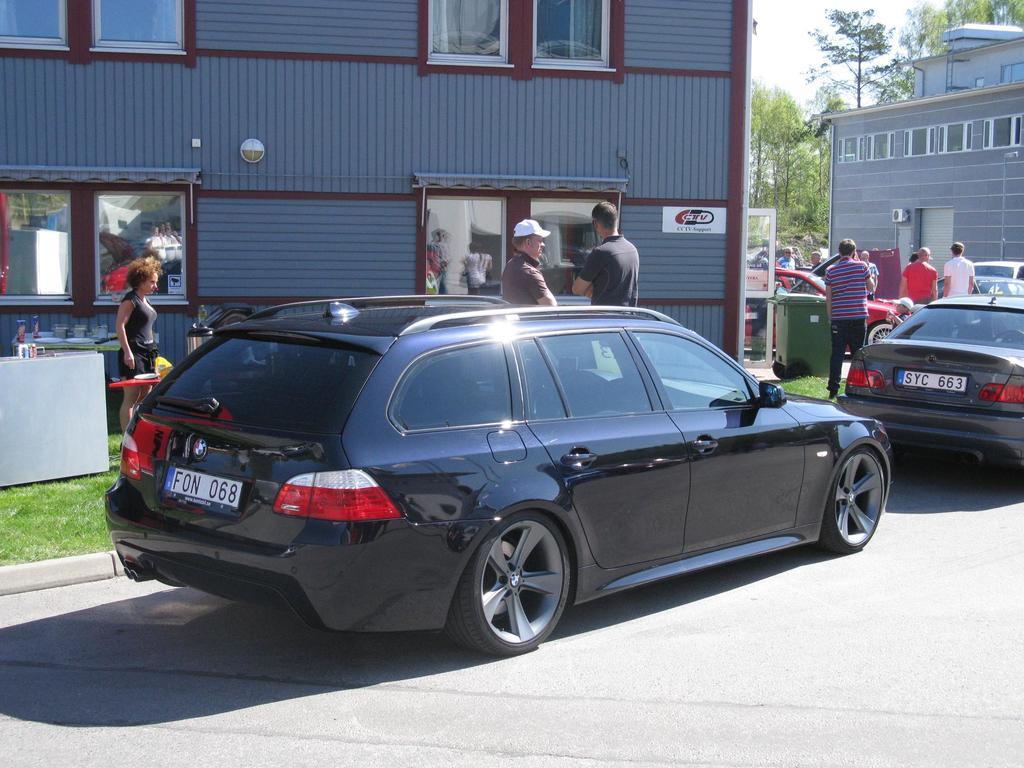What's the license plate to the left?
Ensure brevity in your answer.  Fon 068. What's the license plate to the right?
Offer a terse response. Syc 663. 